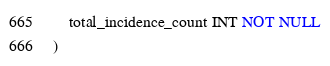<code> <loc_0><loc_0><loc_500><loc_500><_SQL_>    total_incidence_count INT NOT NULL
)</code> 